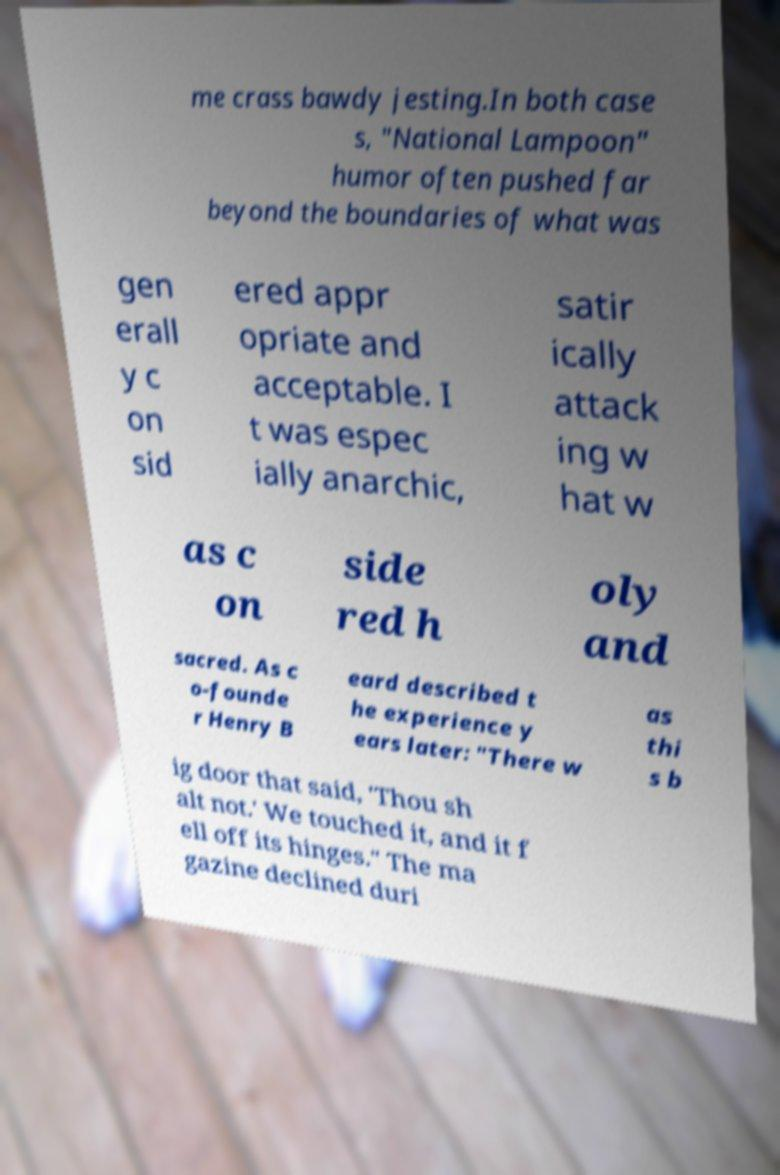Please read and relay the text visible in this image. What does it say? me crass bawdy jesting.In both case s, "National Lampoon" humor often pushed far beyond the boundaries of what was gen erall y c on sid ered appr opriate and acceptable. I t was espec ially anarchic, satir ically attack ing w hat w as c on side red h oly and sacred. As c o-founde r Henry B eard described t he experience y ears later: "There w as thi s b ig door that said, 'Thou sh alt not.' We touched it, and it f ell off its hinges." The ma gazine declined duri 